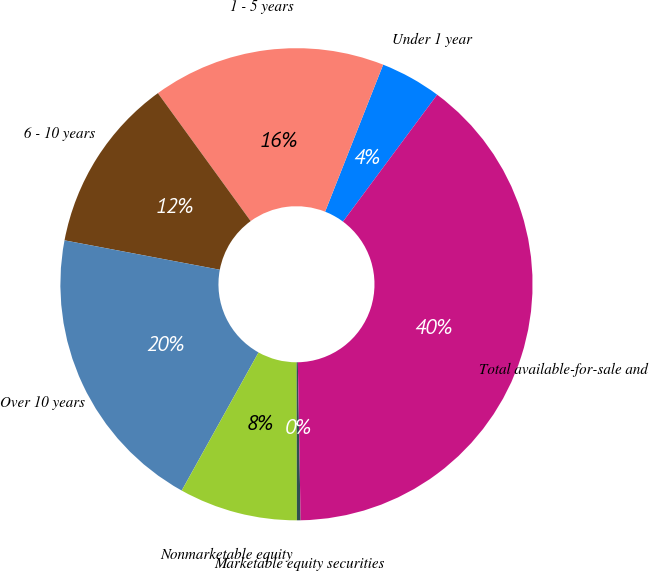Convert chart to OTSL. <chart><loc_0><loc_0><loc_500><loc_500><pie_chart><fcel>Under 1 year<fcel>1 - 5 years<fcel>6 - 10 years<fcel>Over 10 years<fcel>Nonmarketable equity<fcel>Marketable equity securities<fcel>Total available-for-sale and<nl><fcel>4.18%<fcel>15.97%<fcel>12.04%<fcel>19.9%<fcel>8.11%<fcel>0.25%<fcel>39.56%<nl></chart> 